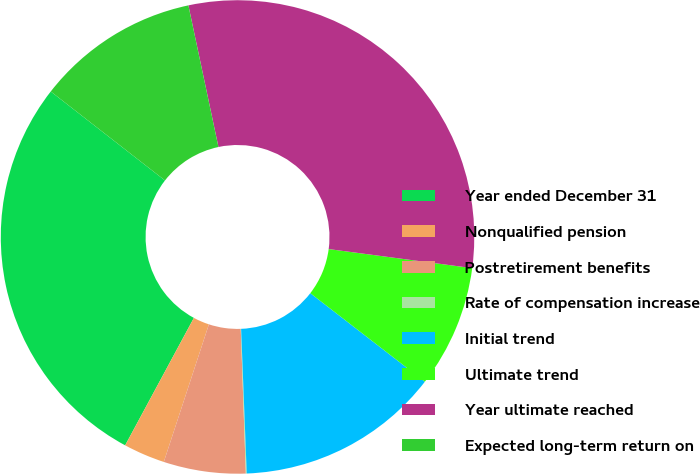Convert chart to OTSL. <chart><loc_0><loc_0><loc_500><loc_500><pie_chart><fcel>Year ended December 31<fcel>Nonqualified pension<fcel>Postretirement benefits<fcel>Rate of compensation increase<fcel>Initial trend<fcel>Ultimate trend<fcel>Year ultimate reached<fcel>Expected long-term return on<nl><fcel>27.66%<fcel>2.83%<fcel>5.6%<fcel>0.06%<fcel>13.91%<fcel>8.37%<fcel>30.43%<fcel>11.14%<nl></chart> 